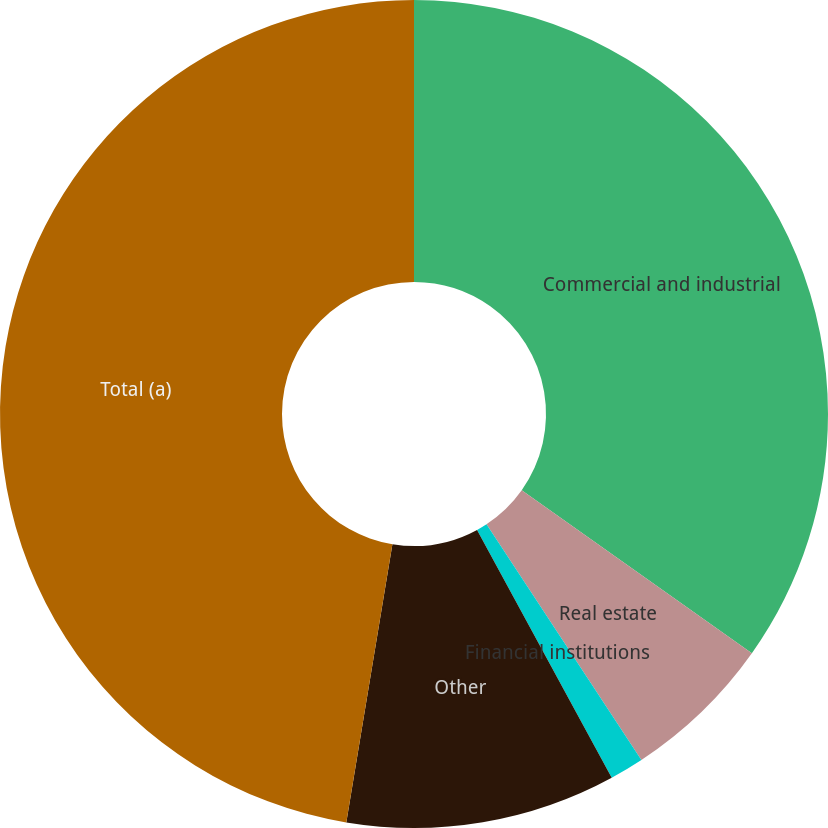Convert chart to OTSL. <chart><loc_0><loc_0><loc_500><loc_500><pie_chart><fcel>Commercial and industrial<fcel>Real estate<fcel>Financial institutions<fcel>Other<fcel>Total (a)<nl><fcel>34.81%<fcel>5.94%<fcel>1.33%<fcel>10.54%<fcel>47.39%<nl></chart> 